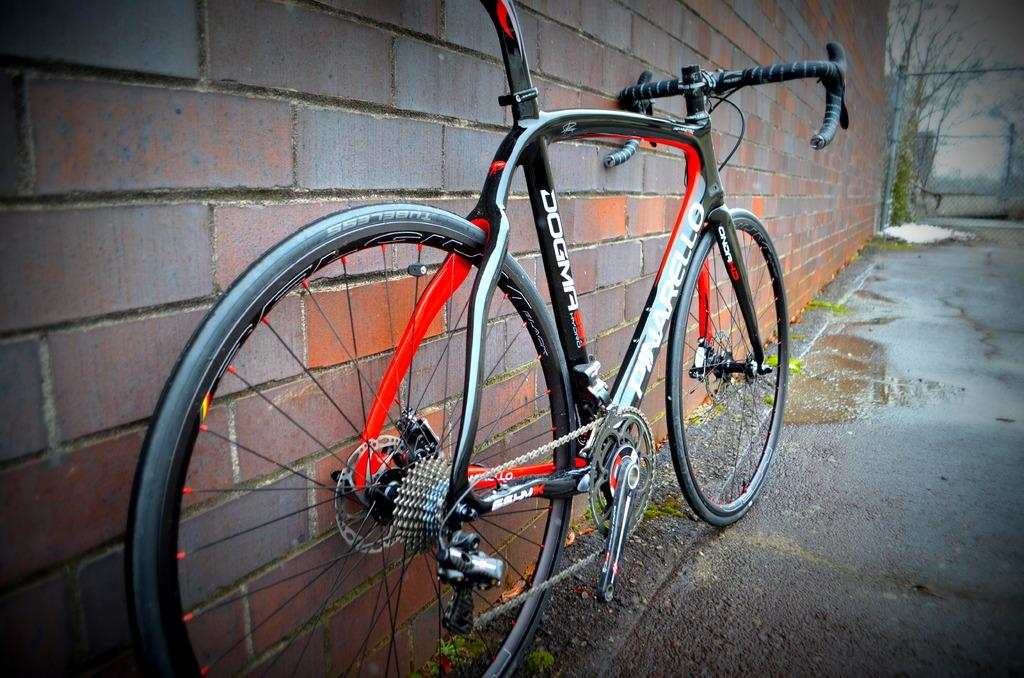What object is on the ground in the image? There is a bicycle on the ground in the image. What can be seen in the background of the image? There is a brick wall, a fence, trees, and the sky visible in the background of the image. How many rings are hanging from the fence in the image? There are no rings visible in the image; the fence is not described as having any rings. 